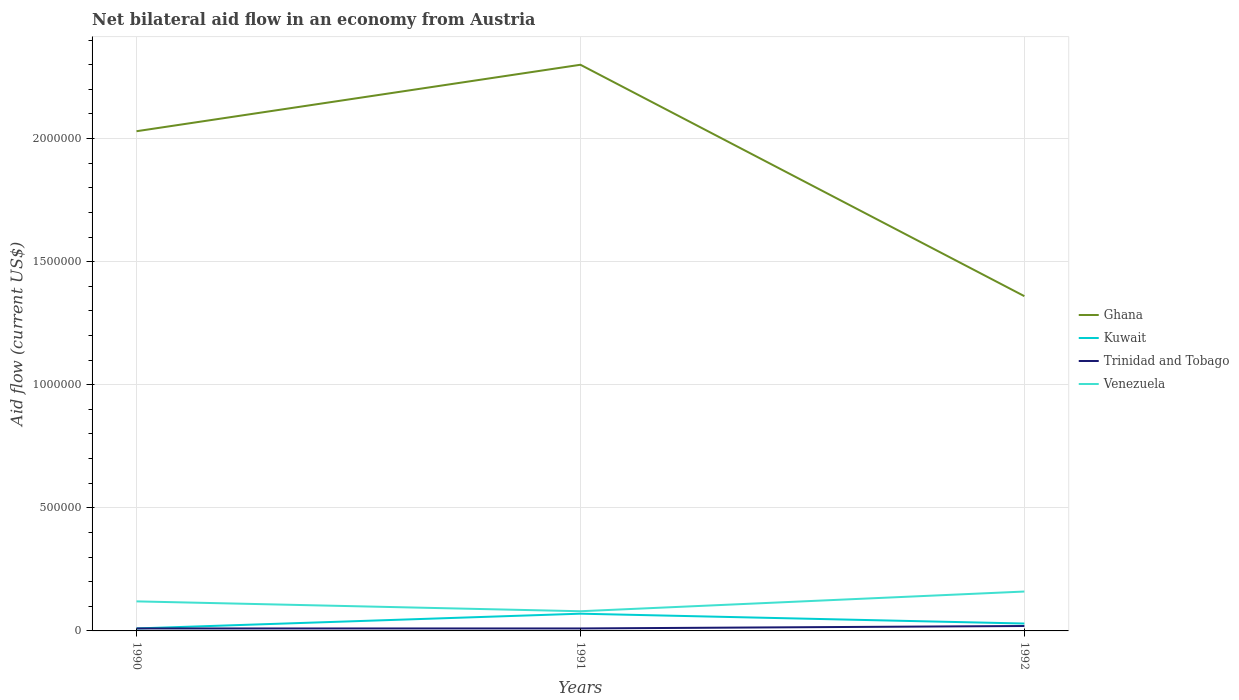Is the number of lines equal to the number of legend labels?
Make the answer very short. Yes. Across all years, what is the maximum net bilateral aid flow in Kuwait?
Offer a very short reply. 10000. What is the total net bilateral aid flow in Venezuela in the graph?
Provide a succinct answer. 4.00e+04. What is the difference between the highest and the lowest net bilateral aid flow in Kuwait?
Make the answer very short. 1. Are the values on the major ticks of Y-axis written in scientific E-notation?
Keep it short and to the point. No. Does the graph contain grids?
Offer a very short reply. Yes. How many legend labels are there?
Ensure brevity in your answer.  4. What is the title of the graph?
Your answer should be compact. Net bilateral aid flow in an economy from Austria. Does "Latin America(developing only)" appear as one of the legend labels in the graph?
Give a very brief answer. No. What is the Aid flow (current US$) in Ghana in 1990?
Your response must be concise. 2.03e+06. What is the Aid flow (current US$) in Ghana in 1991?
Ensure brevity in your answer.  2.30e+06. What is the Aid flow (current US$) of Ghana in 1992?
Ensure brevity in your answer.  1.36e+06. What is the Aid flow (current US$) of Kuwait in 1992?
Ensure brevity in your answer.  3.00e+04. What is the Aid flow (current US$) of Trinidad and Tobago in 1992?
Provide a succinct answer. 2.00e+04. What is the Aid flow (current US$) in Venezuela in 1992?
Ensure brevity in your answer.  1.60e+05. Across all years, what is the maximum Aid flow (current US$) of Ghana?
Your answer should be compact. 2.30e+06. Across all years, what is the maximum Aid flow (current US$) in Venezuela?
Your answer should be very brief. 1.60e+05. Across all years, what is the minimum Aid flow (current US$) of Ghana?
Give a very brief answer. 1.36e+06. Across all years, what is the minimum Aid flow (current US$) of Kuwait?
Offer a very short reply. 10000. Across all years, what is the minimum Aid flow (current US$) in Trinidad and Tobago?
Your response must be concise. 10000. What is the total Aid flow (current US$) in Ghana in the graph?
Keep it short and to the point. 5.69e+06. What is the total Aid flow (current US$) in Kuwait in the graph?
Ensure brevity in your answer.  1.10e+05. What is the total Aid flow (current US$) of Trinidad and Tobago in the graph?
Provide a succinct answer. 4.00e+04. What is the total Aid flow (current US$) of Venezuela in the graph?
Provide a succinct answer. 3.60e+05. What is the difference between the Aid flow (current US$) of Kuwait in 1990 and that in 1991?
Provide a short and direct response. -6.00e+04. What is the difference between the Aid flow (current US$) in Trinidad and Tobago in 1990 and that in 1991?
Provide a short and direct response. 0. What is the difference between the Aid flow (current US$) in Ghana in 1990 and that in 1992?
Give a very brief answer. 6.70e+05. What is the difference between the Aid flow (current US$) of Trinidad and Tobago in 1990 and that in 1992?
Provide a short and direct response. -10000. What is the difference between the Aid flow (current US$) of Venezuela in 1990 and that in 1992?
Make the answer very short. -4.00e+04. What is the difference between the Aid flow (current US$) in Ghana in 1991 and that in 1992?
Provide a short and direct response. 9.40e+05. What is the difference between the Aid flow (current US$) in Ghana in 1990 and the Aid flow (current US$) in Kuwait in 1991?
Give a very brief answer. 1.96e+06. What is the difference between the Aid flow (current US$) in Ghana in 1990 and the Aid flow (current US$) in Trinidad and Tobago in 1991?
Give a very brief answer. 2.02e+06. What is the difference between the Aid flow (current US$) of Ghana in 1990 and the Aid flow (current US$) of Venezuela in 1991?
Provide a succinct answer. 1.95e+06. What is the difference between the Aid flow (current US$) in Kuwait in 1990 and the Aid flow (current US$) in Trinidad and Tobago in 1991?
Keep it short and to the point. 0. What is the difference between the Aid flow (current US$) of Kuwait in 1990 and the Aid flow (current US$) of Venezuela in 1991?
Provide a succinct answer. -7.00e+04. What is the difference between the Aid flow (current US$) of Trinidad and Tobago in 1990 and the Aid flow (current US$) of Venezuela in 1991?
Offer a very short reply. -7.00e+04. What is the difference between the Aid flow (current US$) in Ghana in 1990 and the Aid flow (current US$) in Trinidad and Tobago in 1992?
Your answer should be very brief. 2.01e+06. What is the difference between the Aid flow (current US$) in Ghana in 1990 and the Aid flow (current US$) in Venezuela in 1992?
Offer a very short reply. 1.87e+06. What is the difference between the Aid flow (current US$) in Kuwait in 1990 and the Aid flow (current US$) in Trinidad and Tobago in 1992?
Your answer should be very brief. -10000. What is the difference between the Aid flow (current US$) of Kuwait in 1990 and the Aid flow (current US$) of Venezuela in 1992?
Offer a terse response. -1.50e+05. What is the difference between the Aid flow (current US$) of Trinidad and Tobago in 1990 and the Aid flow (current US$) of Venezuela in 1992?
Make the answer very short. -1.50e+05. What is the difference between the Aid flow (current US$) of Ghana in 1991 and the Aid flow (current US$) of Kuwait in 1992?
Ensure brevity in your answer.  2.27e+06. What is the difference between the Aid flow (current US$) in Ghana in 1991 and the Aid flow (current US$) in Trinidad and Tobago in 1992?
Offer a very short reply. 2.28e+06. What is the difference between the Aid flow (current US$) in Ghana in 1991 and the Aid flow (current US$) in Venezuela in 1992?
Offer a terse response. 2.14e+06. What is the difference between the Aid flow (current US$) of Kuwait in 1991 and the Aid flow (current US$) of Venezuela in 1992?
Provide a short and direct response. -9.00e+04. What is the average Aid flow (current US$) of Ghana per year?
Offer a terse response. 1.90e+06. What is the average Aid flow (current US$) of Kuwait per year?
Give a very brief answer. 3.67e+04. What is the average Aid flow (current US$) in Trinidad and Tobago per year?
Provide a succinct answer. 1.33e+04. In the year 1990, what is the difference between the Aid flow (current US$) in Ghana and Aid flow (current US$) in Kuwait?
Ensure brevity in your answer.  2.02e+06. In the year 1990, what is the difference between the Aid flow (current US$) in Ghana and Aid flow (current US$) in Trinidad and Tobago?
Provide a short and direct response. 2.02e+06. In the year 1990, what is the difference between the Aid flow (current US$) of Ghana and Aid flow (current US$) of Venezuela?
Ensure brevity in your answer.  1.91e+06. In the year 1990, what is the difference between the Aid flow (current US$) in Kuwait and Aid flow (current US$) in Trinidad and Tobago?
Offer a very short reply. 0. In the year 1991, what is the difference between the Aid flow (current US$) of Ghana and Aid flow (current US$) of Kuwait?
Your answer should be very brief. 2.23e+06. In the year 1991, what is the difference between the Aid flow (current US$) of Ghana and Aid flow (current US$) of Trinidad and Tobago?
Give a very brief answer. 2.29e+06. In the year 1991, what is the difference between the Aid flow (current US$) of Ghana and Aid flow (current US$) of Venezuela?
Make the answer very short. 2.22e+06. In the year 1991, what is the difference between the Aid flow (current US$) of Kuwait and Aid flow (current US$) of Venezuela?
Your response must be concise. -10000. In the year 1992, what is the difference between the Aid flow (current US$) in Ghana and Aid flow (current US$) in Kuwait?
Make the answer very short. 1.33e+06. In the year 1992, what is the difference between the Aid flow (current US$) of Ghana and Aid flow (current US$) of Trinidad and Tobago?
Offer a very short reply. 1.34e+06. In the year 1992, what is the difference between the Aid flow (current US$) in Ghana and Aid flow (current US$) in Venezuela?
Your answer should be compact. 1.20e+06. In the year 1992, what is the difference between the Aid flow (current US$) in Kuwait and Aid flow (current US$) in Trinidad and Tobago?
Make the answer very short. 10000. In the year 1992, what is the difference between the Aid flow (current US$) in Trinidad and Tobago and Aid flow (current US$) in Venezuela?
Give a very brief answer. -1.40e+05. What is the ratio of the Aid flow (current US$) in Ghana in 1990 to that in 1991?
Provide a succinct answer. 0.88. What is the ratio of the Aid flow (current US$) in Kuwait in 1990 to that in 1991?
Your answer should be very brief. 0.14. What is the ratio of the Aid flow (current US$) of Venezuela in 1990 to that in 1991?
Offer a very short reply. 1.5. What is the ratio of the Aid flow (current US$) in Ghana in 1990 to that in 1992?
Your response must be concise. 1.49. What is the ratio of the Aid flow (current US$) of Kuwait in 1990 to that in 1992?
Provide a short and direct response. 0.33. What is the ratio of the Aid flow (current US$) of Trinidad and Tobago in 1990 to that in 1992?
Give a very brief answer. 0.5. What is the ratio of the Aid flow (current US$) of Venezuela in 1990 to that in 1992?
Provide a succinct answer. 0.75. What is the ratio of the Aid flow (current US$) in Ghana in 1991 to that in 1992?
Offer a very short reply. 1.69. What is the ratio of the Aid flow (current US$) in Kuwait in 1991 to that in 1992?
Provide a short and direct response. 2.33. What is the ratio of the Aid flow (current US$) in Trinidad and Tobago in 1991 to that in 1992?
Make the answer very short. 0.5. What is the ratio of the Aid flow (current US$) of Venezuela in 1991 to that in 1992?
Ensure brevity in your answer.  0.5. What is the difference between the highest and the second highest Aid flow (current US$) of Kuwait?
Provide a succinct answer. 4.00e+04. What is the difference between the highest and the second highest Aid flow (current US$) of Trinidad and Tobago?
Provide a succinct answer. 10000. What is the difference between the highest and the second highest Aid flow (current US$) in Venezuela?
Provide a succinct answer. 4.00e+04. What is the difference between the highest and the lowest Aid flow (current US$) of Ghana?
Offer a terse response. 9.40e+05. What is the difference between the highest and the lowest Aid flow (current US$) in Trinidad and Tobago?
Your response must be concise. 10000. 